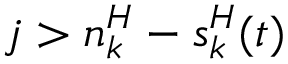Convert formula to latex. <formula><loc_0><loc_0><loc_500><loc_500>j > n _ { k } ^ { H } - s _ { k } ^ { H } ( t )</formula> 